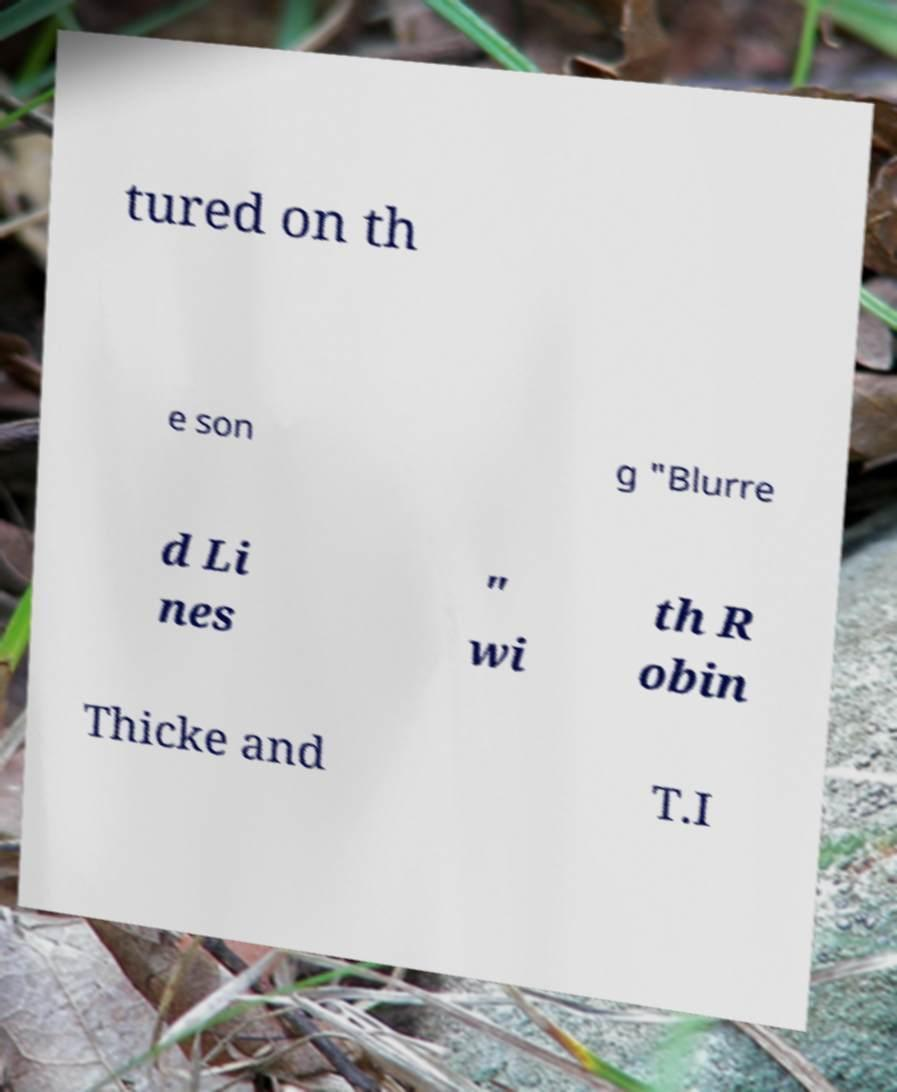There's text embedded in this image that I need extracted. Can you transcribe it verbatim? tured on th e son g "Blurre d Li nes " wi th R obin Thicke and T.I 